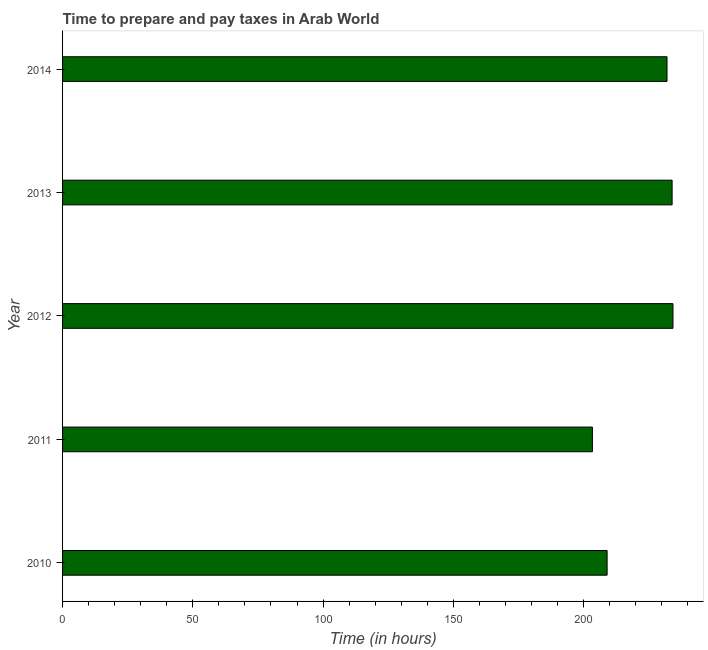What is the title of the graph?
Give a very brief answer. Time to prepare and pay taxes in Arab World. What is the label or title of the X-axis?
Provide a succinct answer. Time (in hours). What is the label or title of the Y-axis?
Offer a very short reply. Year. What is the time to prepare and pay taxes in 2010?
Your response must be concise. 209.05. Across all years, what is the maximum time to prepare and pay taxes?
Your response must be concise. 234.33. Across all years, what is the minimum time to prepare and pay taxes?
Provide a succinct answer. 203.4. In which year was the time to prepare and pay taxes maximum?
Provide a succinct answer. 2012. What is the sum of the time to prepare and pay taxes?
Make the answer very short. 1112.83. What is the difference between the time to prepare and pay taxes in 2010 and 2014?
Offer a very short reply. -23. What is the average time to prepare and pay taxes per year?
Make the answer very short. 222.57. What is the median time to prepare and pay taxes?
Provide a short and direct response. 232.05. Do a majority of the years between 2010 and 2013 (inclusive) have time to prepare and pay taxes greater than 50 hours?
Your answer should be very brief. Yes. What is the ratio of the time to prepare and pay taxes in 2012 to that in 2013?
Offer a terse response. 1. What is the difference between the highest and the second highest time to prepare and pay taxes?
Offer a terse response. 0.33. What is the difference between the highest and the lowest time to prepare and pay taxes?
Ensure brevity in your answer.  30.93. In how many years, is the time to prepare and pay taxes greater than the average time to prepare and pay taxes taken over all years?
Provide a short and direct response. 3. How many bars are there?
Make the answer very short. 5. Are all the bars in the graph horizontal?
Ensure brevity in your answer.  Yes. What is the Time (in hours) in 2010?
Keep it short and to the point. 209.05. What is the Time (in hours) in 2011?
Offer a very short reply. 203.4. What is the Time (in hours) of 2012?
Your answer should be very brief. 234.33. What is the Time (in hours) of 2013?
Your answer should be very brief. 234. What is the Time (in hours) of 2014?
Make the answer very short. 232.05. What is the difference between the Time (in hours) in 2010 and 2011?
Offer a very short reply. 5.65. What is the difference between the Time (in hours) in 2010 and 2012?
Your answer should be compact. -25.28. What is the difference between the Time (in hours) in 2010 and 2013?
Provide a short and direct response. -24.95. What is the difference between the Time (in hours) in 2010 and 2014?
Provide a succinct answer. -23. What is the difference between the Time (in hours) in 2011 and 2012?
Offer a terse response. -30.93. What is the difference between the Time (in hours) in 2011 and 2013?
Give a very brief answer. -30.6. What is the difference between the Time (in hours) in 2011 and 2014?
Keep it short and to the point. -28.65. What is the difference between the Time (in hours) in 2012 and 2013?
Make the answer very short. 0.33. What is the difference between the Time (in hours) in 2012 and 2014?
Ensure brevity in your answer.  2.29. What is the difference between the Time (in hours) in 2013 and 2014?
Provide a short and direct response. 1.95. What is the ratio of the Time (in hours) in 2010 to that in 2011?
Your answer should be very brief. 1.03. What is the ratio of the Time (in hours) in 2010 to that in 2012?
Your response must be concise. 0.89. What is the ratio of the Time (in hours) in 2010 to that in 2013?
Your answer should be very brief. 0.89. What is the ratio of the Time (in hours) in 2010 to that in 2014?
Offer a very short reply. 0.9. What is the ratio of the Time (in hours) in 2011 to that in 2012?
Your answer should be compact. 0.87. What is the ratio of the Time (in hours) in 2011 to that in 2013?
Make the answer very short. 0.87. What is the ratio of the Time (in hours) in 2011 to that in 2014?
Your answer should be compact. 0.88. What is the ratio of the Time (in hours) in 2012 to that in 2013?
Keep it short and to the point. 1. What is the ratio of the Time (in hours) in 2012 to that in 2014?
Offer a very short reply. 1.01. What is the ratio of the Time (in hours) in 2013 to that in 2014?
Provide a succinct answer. 1.01. 